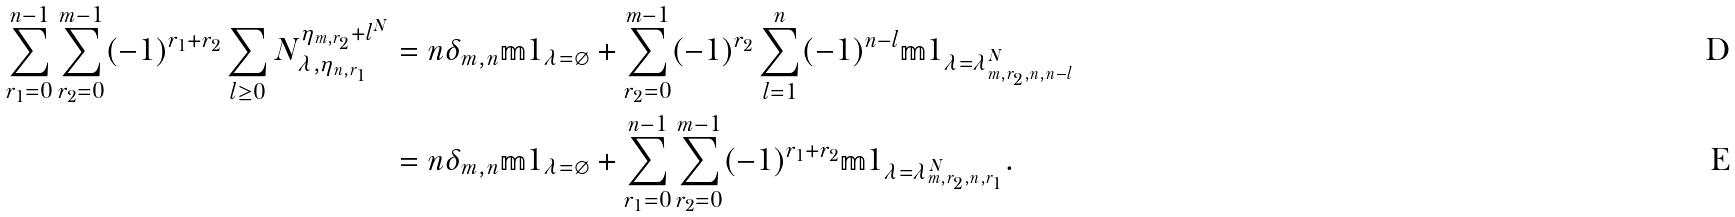Convert formula to latex. <formula><loc_0><loc_0><loc_500><loc_500>\sum _ { r _ { 1 } = 0 } ^ { n - 1 } \sum _ { r _ { 2 } = 0 } ^ { m - 1 } ( - 1 ) ^ { r _ { 1 } + r _ { 2 } } \sum _ { l \geq 0 } N _ { \lambda , \eta _ { n , r _ { 1 } } } ^ { \eta _ { m , r _ { 2 } } + l ^ { N } } & = n \delta _ { m , n } { \mathbb { m } 1 } _ { \lambda = \varnothing } + \sum _ { r _ { 2 } = 0 } ^ { m - 1 } ( - 1 ) ^ { r _ { 2 } } \sum _ { l = 1 } ^ { n } ( - 1 ) ^ { n - l } { \mathbb { m } 1 } _ { \lambda = \lambda ^ { N } _ { m , r _ { 2 } , n , n - l } } \\ & = n \delta _ { m , n } { \mathbb { m } 1 } _ { \lambda = \varnothing } + \sum _ { r _ { 1 } = 0 } ^ { n - 1 } \sum _ { r _ { 2 } = 0 } ^ { m - 1 } ( - 1 ) ^ { r _ { 1 } + r _ { 2 } } { \mathbb { m } 1 } _ { \lambda = \lambda ^ { N } _ { m , r _ { 2 } , n , r _ { 1 } } } .</formula> 